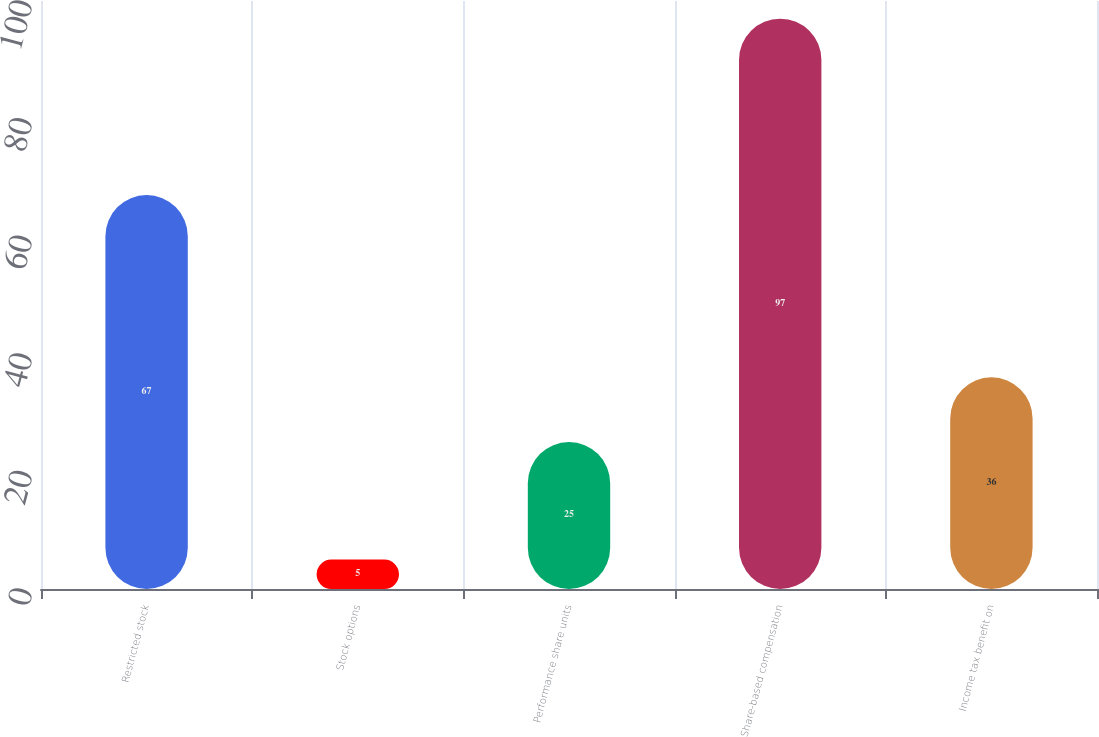Convert chart. <chart><loc_0><loc_0><loc_500><loc_500><bar_chart><fcel>Restricted stock<fcel>Stock options<fcel>Performance share units<fcel>Share-based compensation<fcel>Income tax benefit on<nl><fcel>67<fcel>5<fcel>25<fcel>97<fcel>36<nl></chart> 